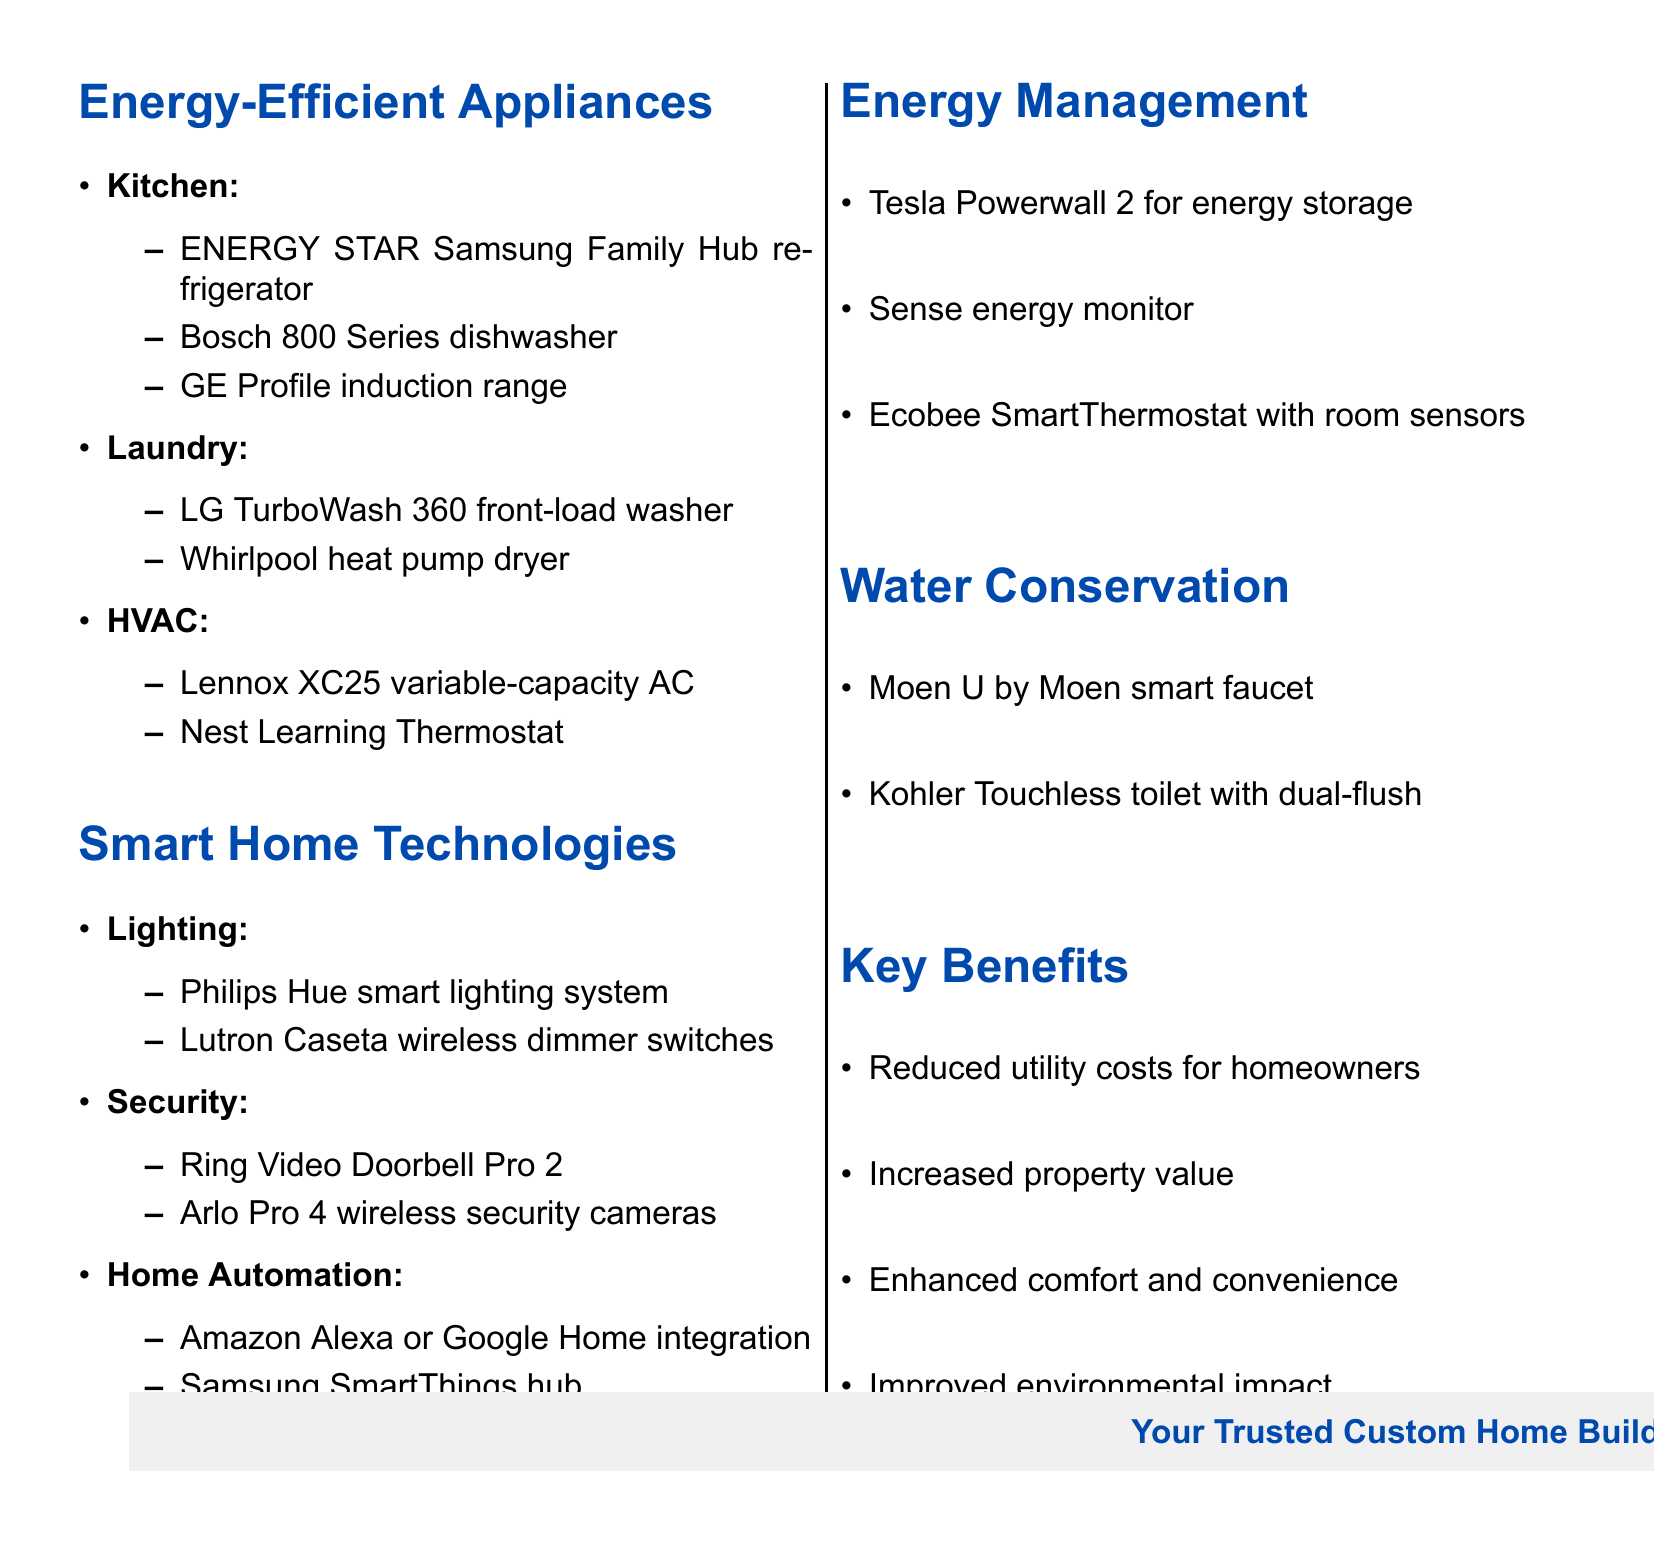What is the first item listed under Kitchen appliances? The first item listed under Kitchen appliances is the ENERGY STAR certified Samsung Family Hub refrigerator.
Answer: ENERGY STAR certified Samsung Family Hub refrigerator How many items are listed in the Laundry category? The Laundry category includes two items: LG TurboWash 360 front-load washer and Whirlpool heat pump dryer.
Answer: 2 What smart home technology is listed for Home Automation? The document lists Amazon Alexa or Google Home integration and Samsung SmartThings hub for Home Automation.
Answer: Amazon Alexa or Google Home integration What is one of the energy management solutions mentioned? The document mentions Tesla Powerwall 2 for energy storage as one of the energy management solutions.
Answer: Tesla Powerwall 2 How many benefits are listed in the Key Benefits section? There are four key benefits listed in the Key Benefits section.
Answer: 4 Which category includes the Moen U by Moen smart faucet? The Moen U by Moen smart faucet is included in the Water Conservation category.
Answer: Water Conservation What is the common feature of the Bosch 800 Series dishwasher? The Bosch 800 Series dishwasher features an EcoSilence motor, promoting energy efficiency.
Answer: EcoSilence motor Which brand is associated with the touchless toilet? The touchless toilet mentioned is from Kohler, which features dual-flush technology.
Answer: Kohler 